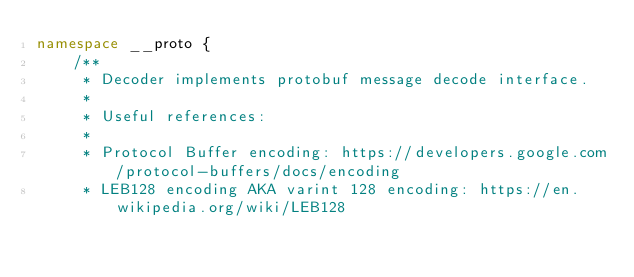Convert code to text. <code><loc_0><loc_0><loc_500><loc_500><_TypeScript_>namespace __proto {
    /**
     * Decoder implements protobuf message decode interface.
     *
     * Useful references:
     *
     * Protocol Buffer encoding: https://developers.google.com/protocol-buffers/docs/encoding
     * LEB128 encoding AKA varint 128 encoding: https://en.wikipedia.org/wiki/LEB128</code> 